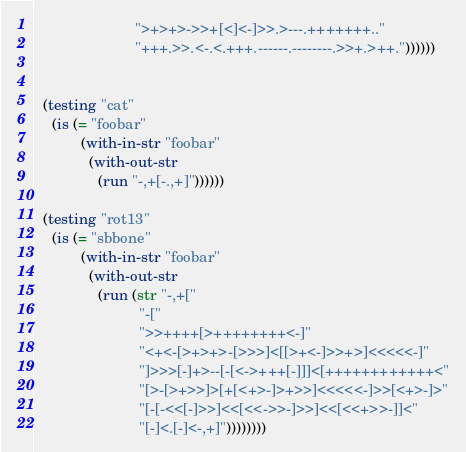<code> <loc_0><loc_0><loc_500><loc_500><_Clojure_>                        ">+>+>->>+[<]<-]>>.>---.+++++++.."
                        "+++.>>.<-.<.+++.------.--------.>>+.>++."))))))


  (testing "cat"
    (is (= "foobar"
           (with-in-str "foobar"
             (with-out-str
               (run "-,+[-.,+]"))))))

  (testing "rot13"
    (is (= "sbbone"
           (with-in-str "foobar"
             (with-out-str
               (run (str "-,+["
                         "-["
                         ">>++++[>++++++++<-]"
                         "<+<-[>+>+>-[>>>]<[[>+<-]>>+>]<<<<<-]"
                         "]>>>[-]+>--[-[<->+++[-]]]<[++++++++++++<"
                         "[>-[>+>>]>[+[<+>-]>+>>]<<<<<-]>>[<+>-]>"
                         "[-[-<<[-]>>]<<[<<->>-]>>]<<[<<+>>-]]<"
                         "[-]<.[-]<-,+]"))))))))
</code> 